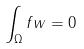<formula> <loc_0><loc_0><loc_500><loc_500>\int _ { \Omega } f w = 0</formula> 